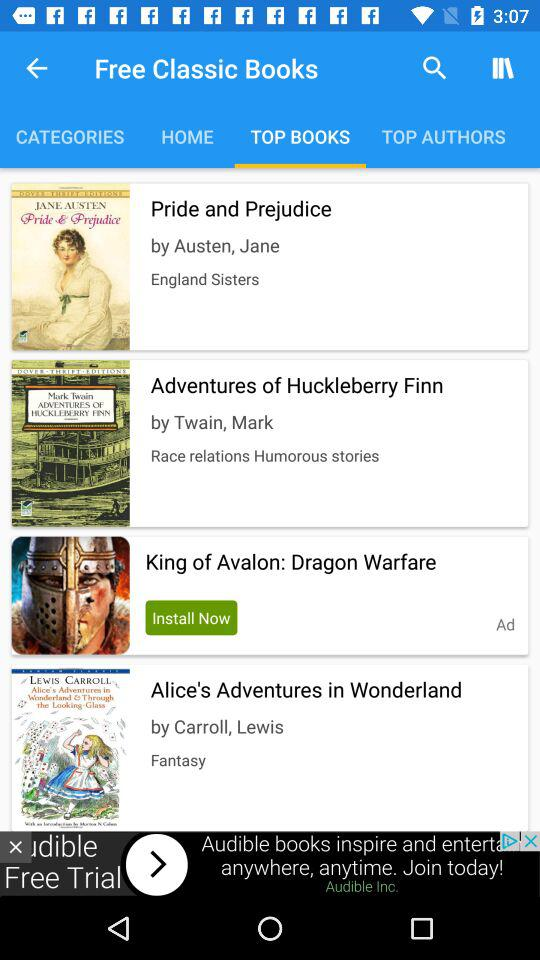How many items have an author name?
Answer the question using a single word or phrase. 3 